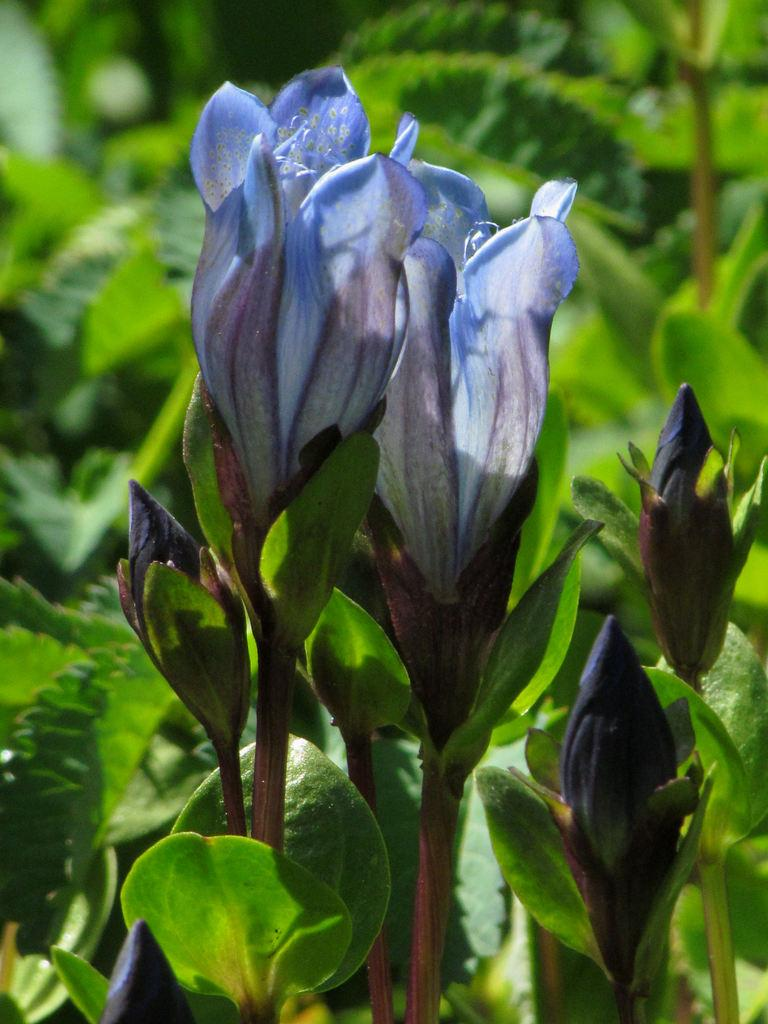What type of living organisms can be seen in the image? There are flowers and plants visible in the image. Can you describe the plants in the image? The plants in the image are not specified, but they are present alongside the flowers. What type of cream is being used to paint the flowers in the image? There is no cream or painting activity present in the image; it features flowers and plants. What kind of cracker is visible in the image? There is no cracker present in the image. 